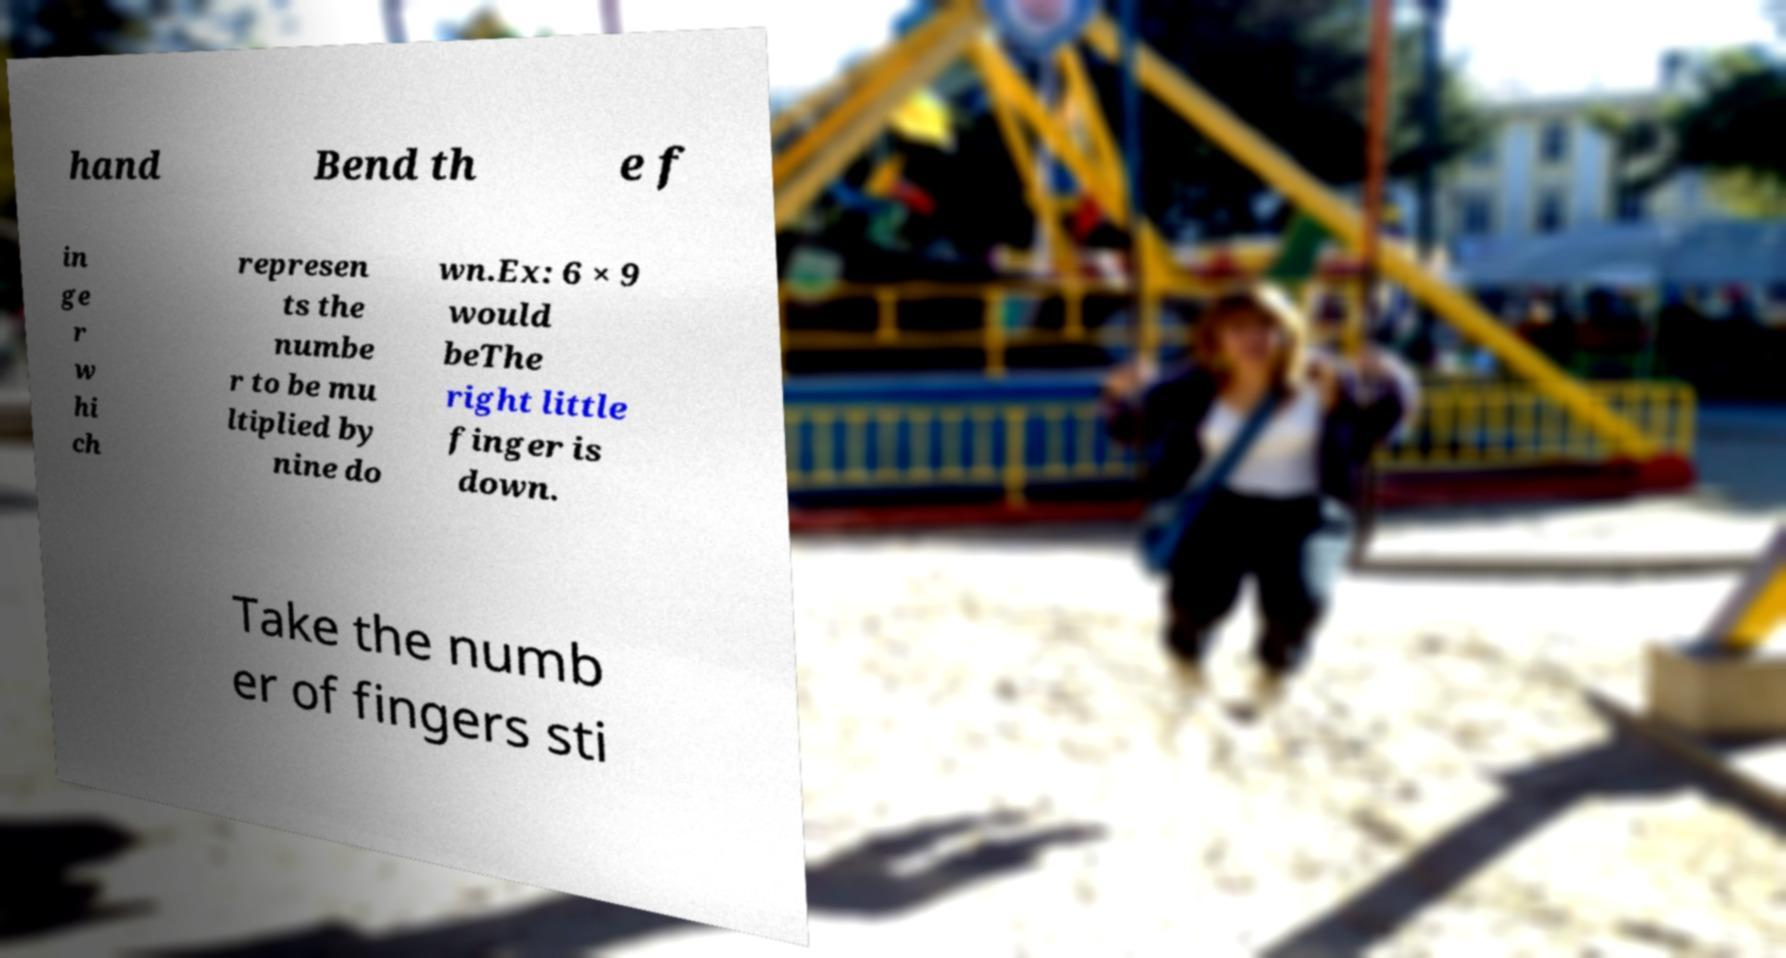Could you assist in decoding the text presented in this image and type it out clearly? hand Bend th e f in ge r w hi ch represen ts the numbe r to be mu ltiplied by nine do wn.Ex: 6 × 9 would beThe right little finger is down. Take the numb er of fingers sti 